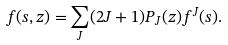<formula> <loc_0><loc_0><loc_500><loc_500>f ( s , z ) = \sum _ { J } ( 2 J + 1 ) P _ { J } ( z ) f ^ { J } ( s ) .</formula> 